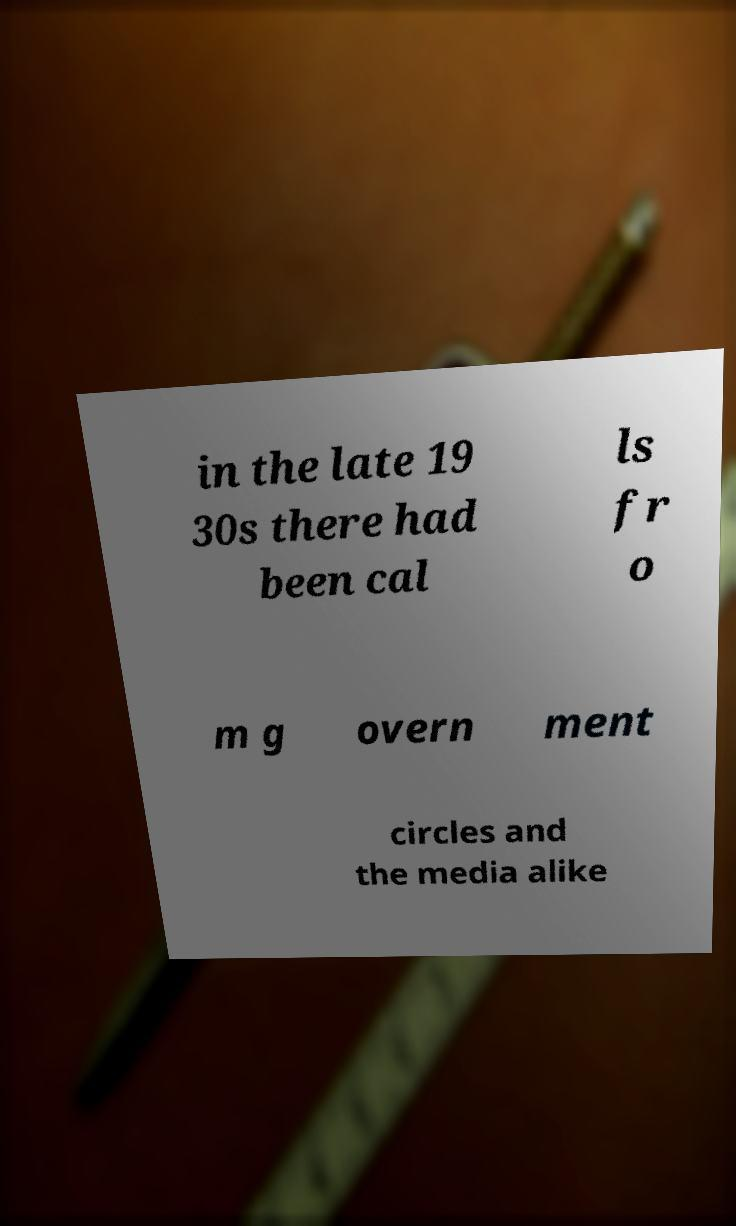What messages or text are displayed in this image? I need them in a readable, typed format. in the late 19 30s there had been cal ls fr o m g overn ment circles and the media alike 